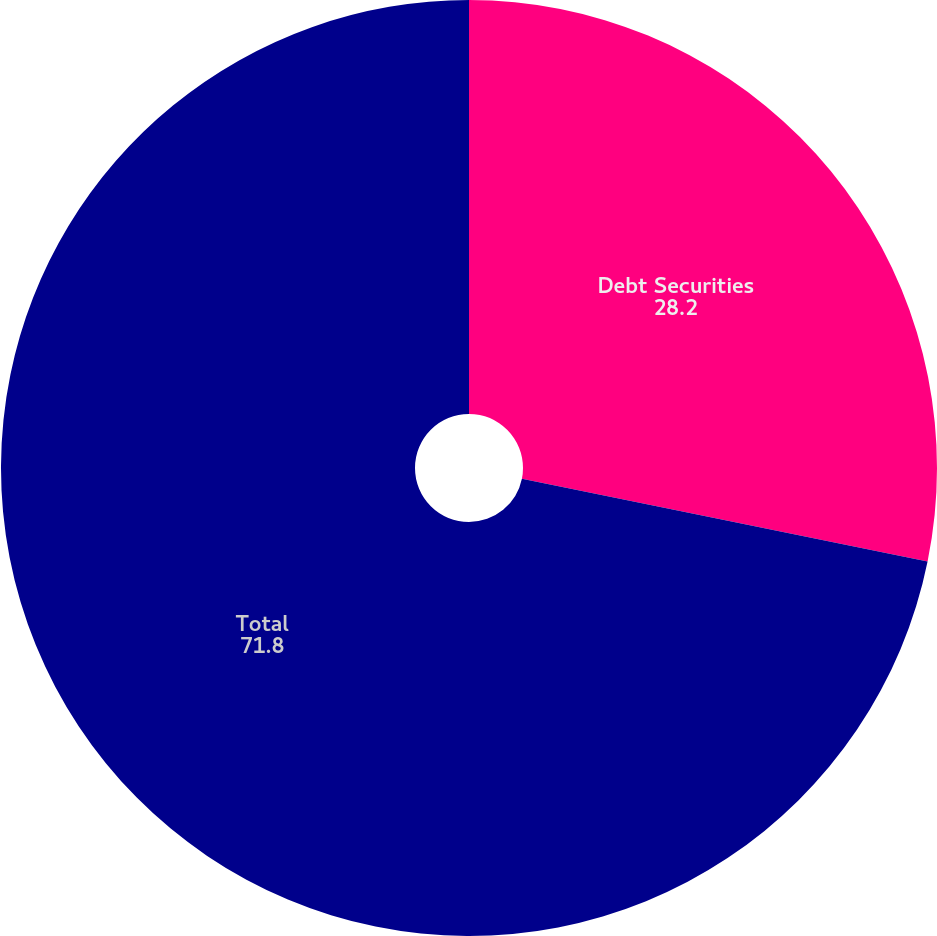<chart> <loc_0><loc_0><loc_500><loc_500><pie_chart><fcel>Debt Securities<fcel>Total<nl><fcel>28.2%<fcel>71.8%<nl></chart> 